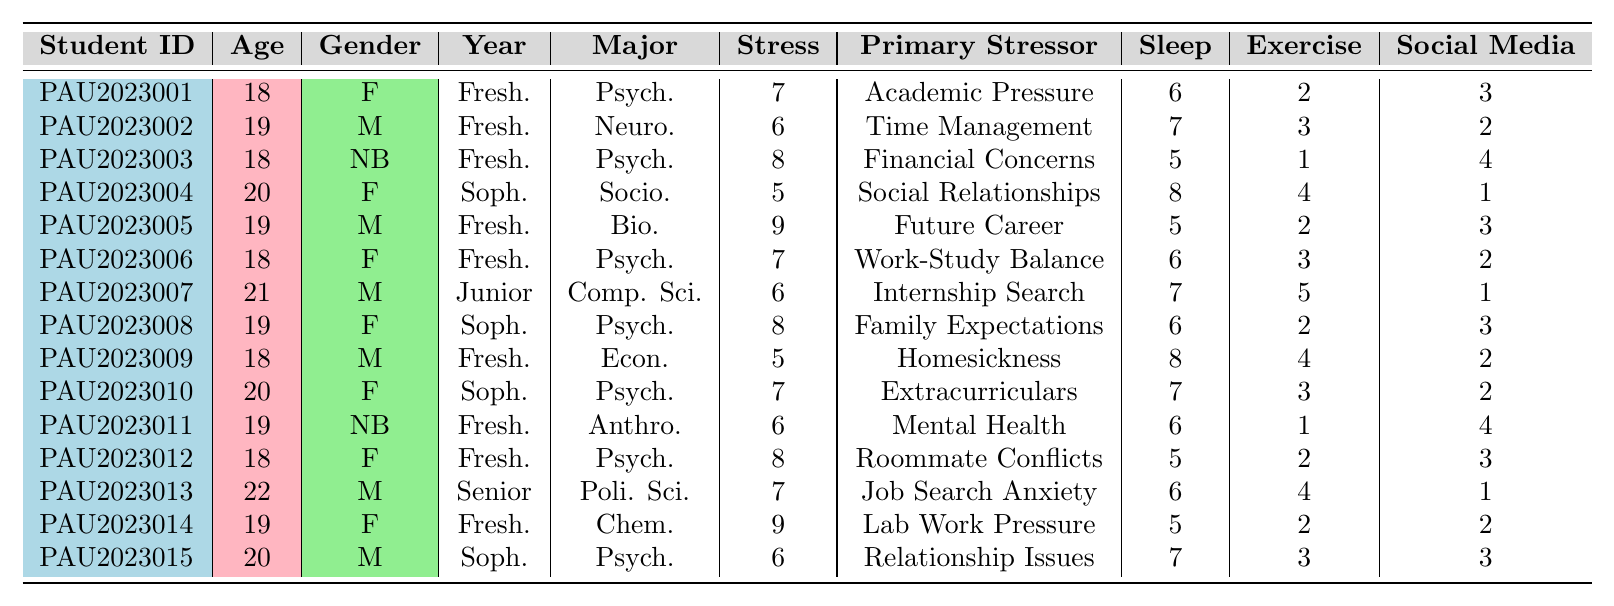What is the highest stress level recorded among the students? By scanning the "Stress Level (1-10)" column, the highest number is identified, which is 9, found for two students with IDs PAU2023005 and PAU2023014.
Answer: 9 How many students report a stress level of 6? A quick count of the entries showing a stress level of 6 gives us 4 students: PAU2023002, PAU2023007, PAU2023011, and PAU2023015.
Answer: 4 What is the average number of hours of sleep reported by freshmen? The sleep values for freshmen are 6, 7, 5, 6, 8, 5, and 6. Summing these gives 43 hours for 7 students, and the average is 43/7 = 6.14, which we can round to 6.1.
Answer: 6.1 Do any students use more than 3 hours of social media per day? Checking the "Social Media Usage (hours/day)" column, we find that students PAU2023003, PAU2023009, and PAU2023011 use more than 3 hours per day.
Answer: Yes Which female student has the lowest stress level? Identifying female students, we see that PAU2023004 has the lowest stress level of 5. We confirm that she is the only female with this score.
Answer: PAU2023004 What is the median stress level among all students? To find the median, first list the stress levels in ascending order: 5, 5, 6, 6, 6, 6, 7, 7, 7, 8, 8, 8, 9, 9. There are 15 data points, so the median is the 8th value, which is 7.
Answer: 7 How many students report "Financial Concerns" as their primary stressor? Looking at the "Primary Stressor" column, we see that only one student, PAU2023003, reports "Financial Concerns."
Answer: 1 Is there a correlation between exercise frequency and reported stress levels for the students? Analyzing the data, we would need to check for trends between the "Exercise Frequency" and "Stress Level" columns. Students with higher exercise frequency do not consistently show lower stress levels, indicating no clear correlation.
Answer: No Which major has the most students reporting the highest stress level of 9? From the data, both Psychology (PAU2023005 and PAU2023014) have stress levels of 9. Psychology is the major with the most occurrences at this stress level.
Answer: Psychology What is the average age of students who have a stress level below 7? The students with stress levels below 7 are PAU2023002, PAU2023004, PAU2023007, PAU2023009, and PAU2023015, which have ages 19, 20, 21, 18, and 20 respectively. The total age is 98, and the average age is 98/5 = 19.6.
Answer: 19.6 